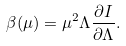<formula> <loc_0><loc_0><loc_500><loc_500>\beta ( \mu ) = \mu ^ { 2 } \Lambda \frac { \partial I } { \partial \Lambda } .</formula> 